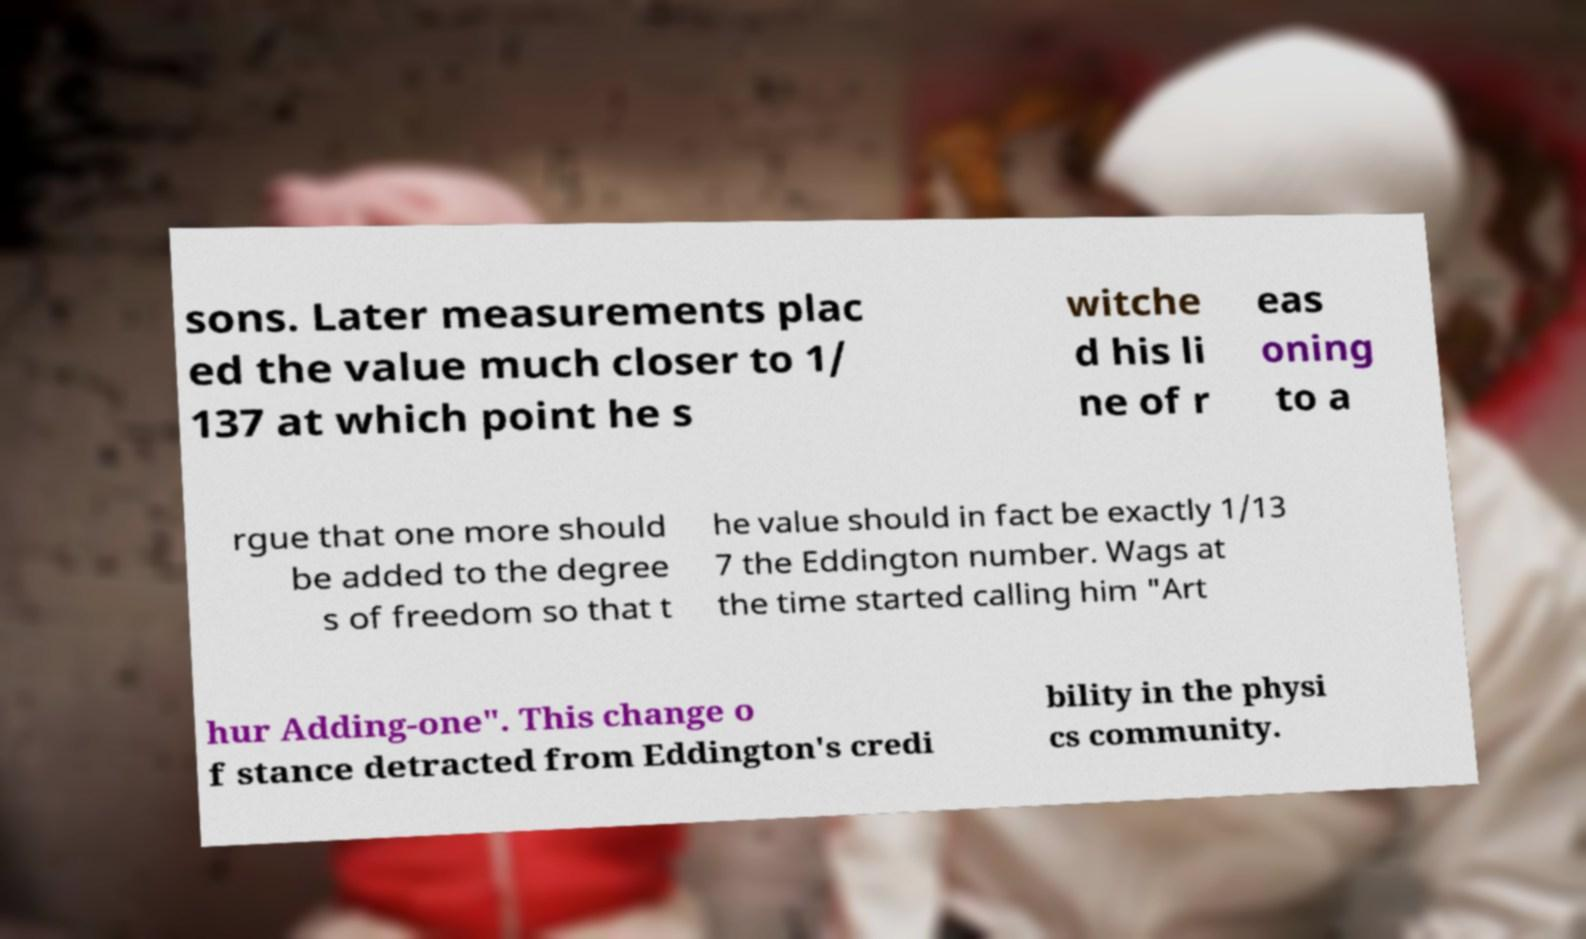For documentation purposes, I need the text within this image transcribed. Could you provide that? sons. Later measurements plac ed the value much closer to 1/ 137 at which point he s witche d his li ne of r eas oning to a rgue that one more should be added to the degree s of freedom so that t he value should in fact be exactly 1/13 7 the Eddington number. Wags at the time started calling him "Art hur Adding-one". This change o f stance detracted from Eddington's credi bility in the physi cs community. 